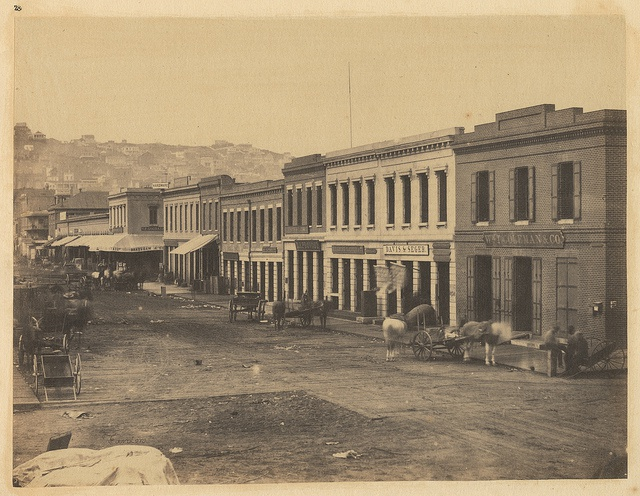Describe the objects in this image and their specific colors. I can see horse in tan, gray, and black tones, horse in tan and gray tones, people in tan, gray, and black tones, people in tan, black, and gray tones, and horse in tan, gray, and black tones in this image. 